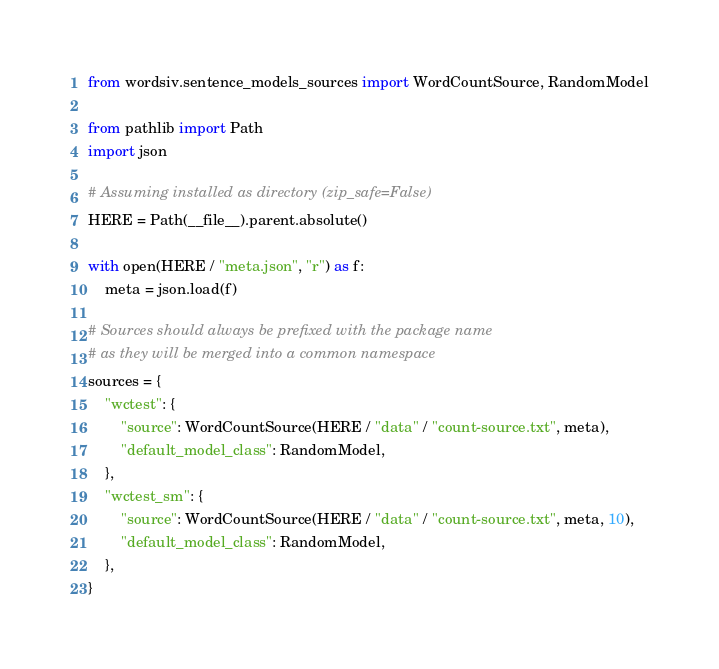Convert code to text. <code><loc_0><loc_0><loc_500><loc_500><_Python_>from wordsiv.sentence_models_sources import WordCountSource, RandomModel

from pathlib import Path
import json

# Assuming installed as directory (zip_safe=False)
HERE = Path(__file__).parent.absolute()

with open(HERE / "meta.json", "r") as f:
    meta = json.load(f)

# Sources should always be prefixed with the package name
# as they will be merged into a common namespace
sources = {
    "wctest": {
        "source": WordCountSource(HERE / "data" / "count-source.txt", meta),
        "default_model_class": RandomModel,
    },
    "wctest_sm": {
        "source": WordCountSource(HERE / "data" / "count-source.txt", meta, 10),
        "default_model_class": RandomModel,
    },
}
</code> 